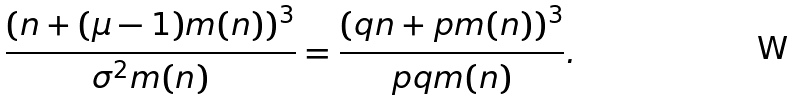<formula> <loc_0><loc_0><loc_500><loc_500>\frac { ( n + ( \mu - 1 ) m ( n ) ) ^ { 3 } } { \sigma ^ { 2 } m ( n ) } & = \frac { ( q n + p m ( n ) ) ^ { 3 } } { p q m ( n ) } .</formula> 